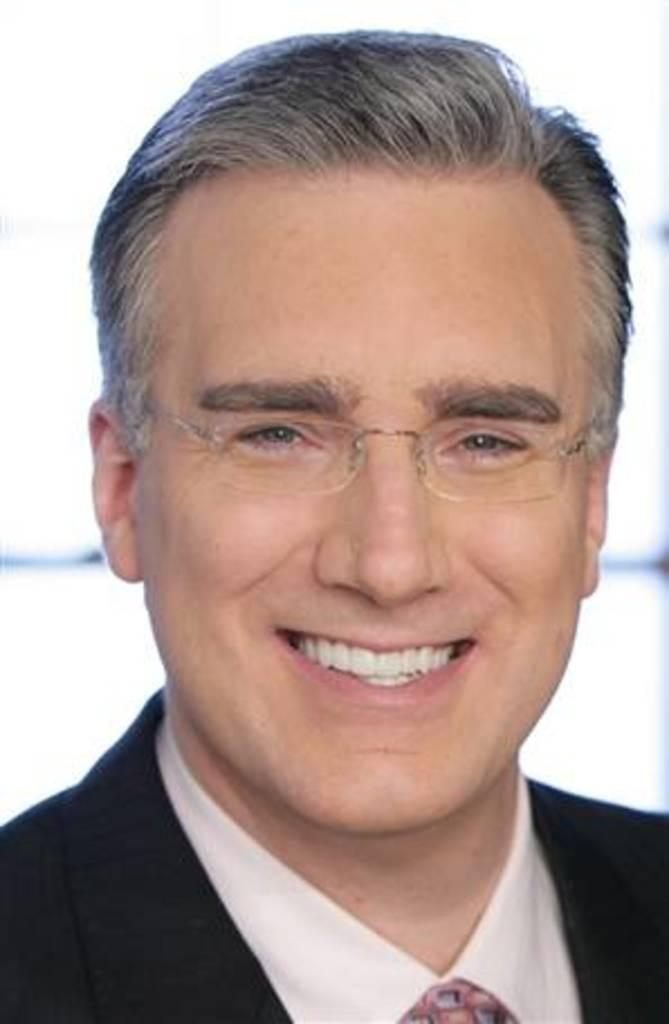Who is present in the image? There is a man in the image. What is the man wearing? The man is wearing clothes and spectacles. What is the man's facial expression? The man is smiling. How would you describe the background of the image? The background of the image is blurred. What type of berry can be seen on the man's shirt in the image? There is no berry visible on the man's shirt in the image. How does the man use his badge in the image? There is no badge present in the image. 